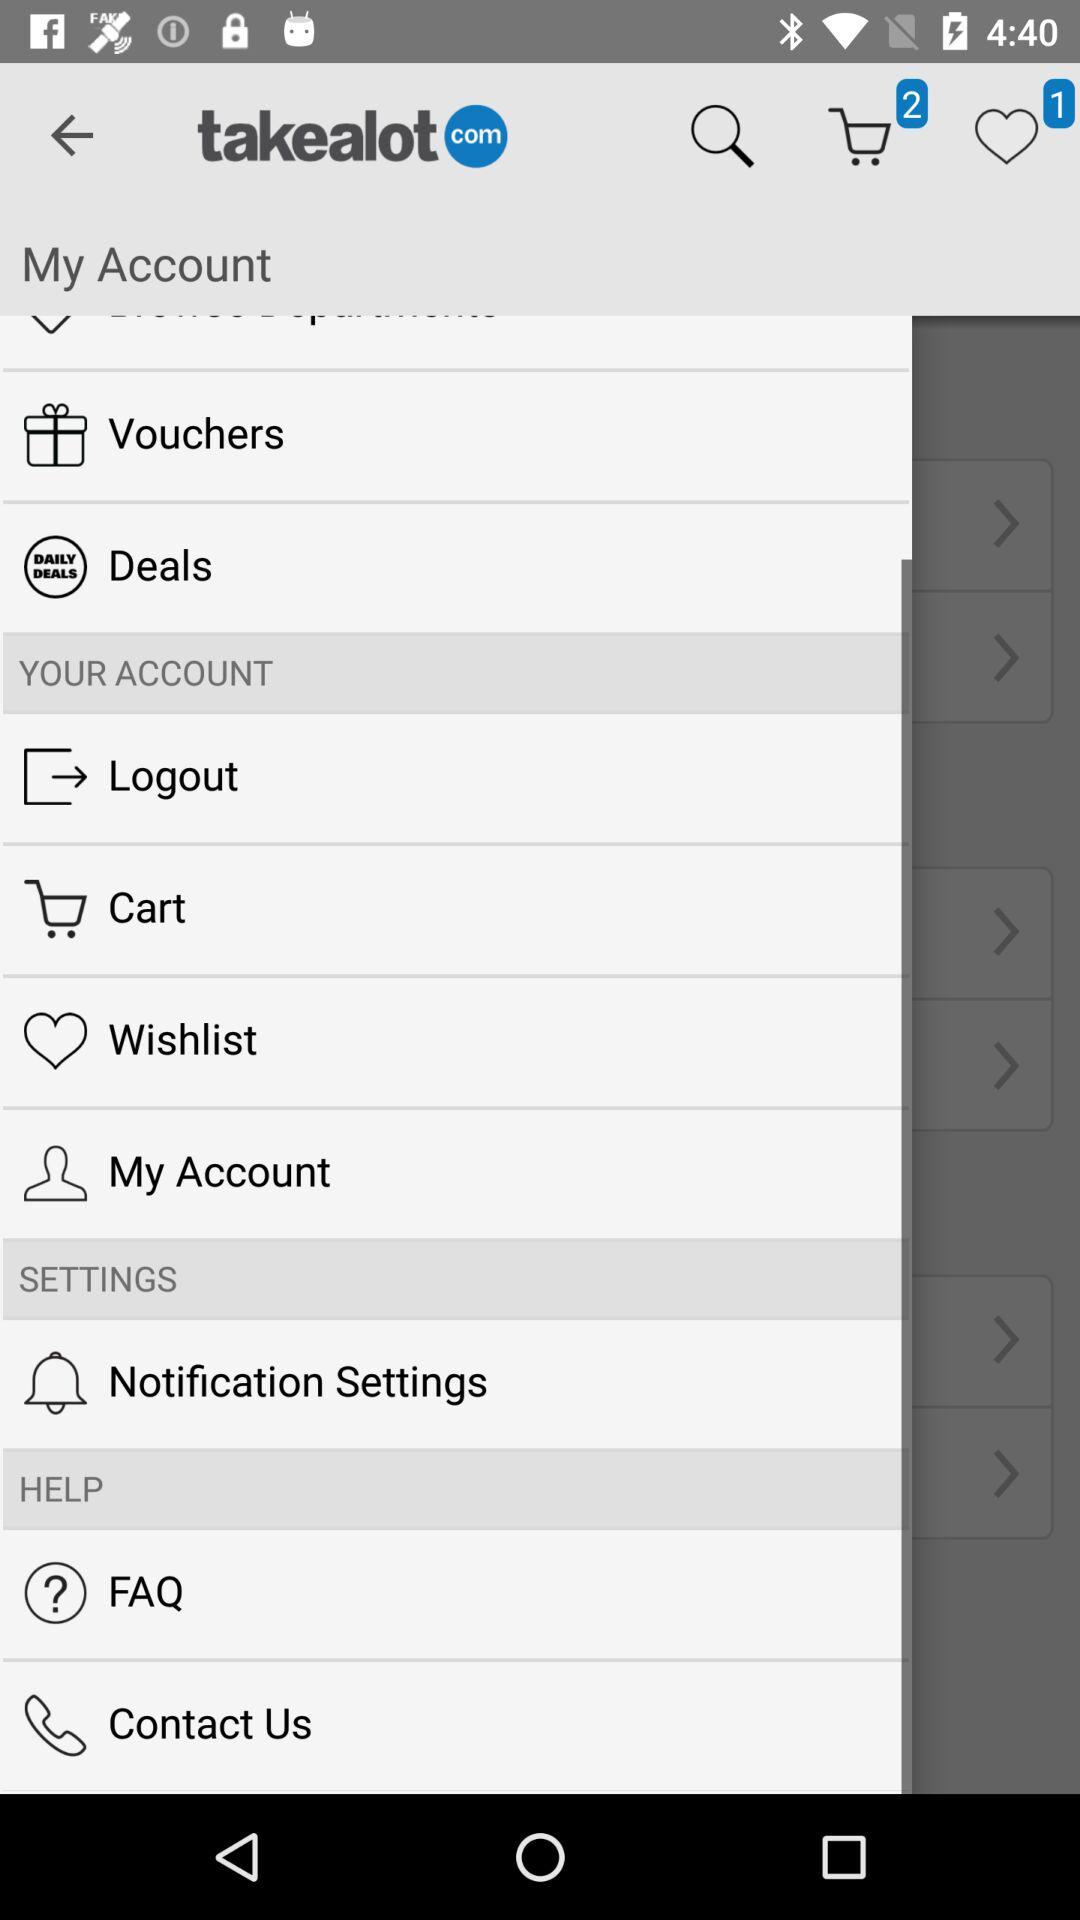How many items are in the shopping cart? There are 2 items in the shopping cart. 